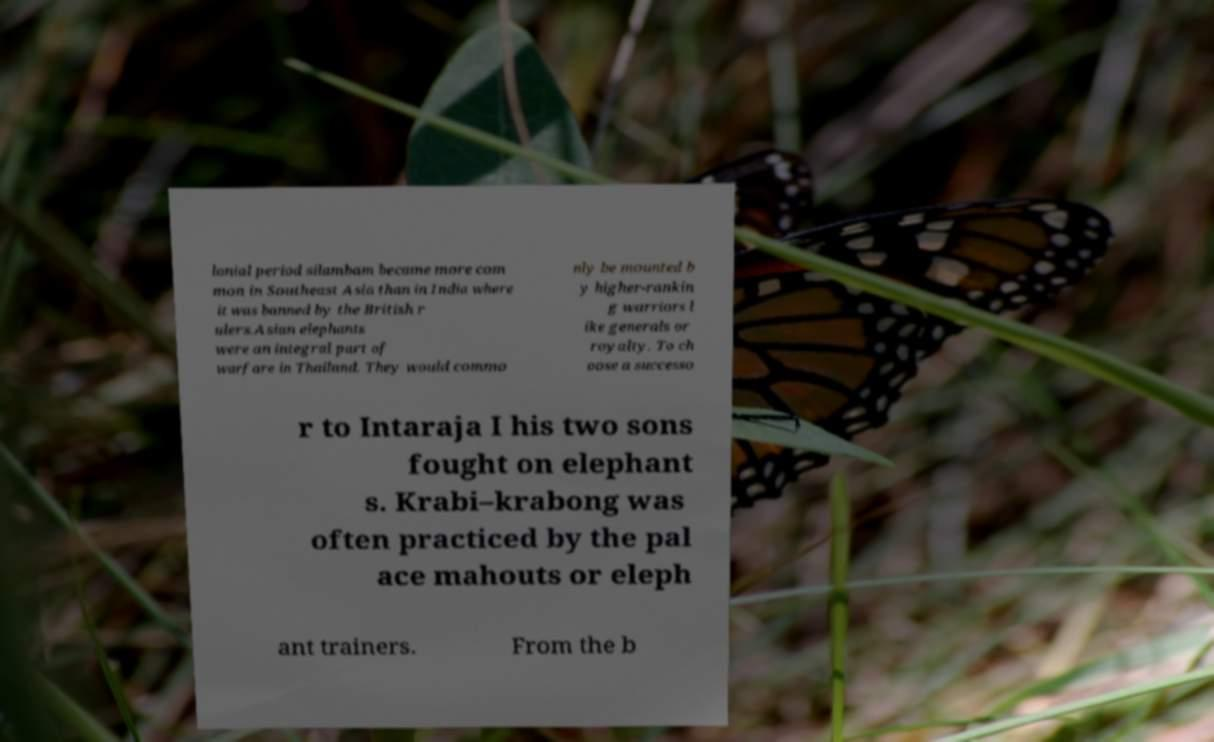Could you extract and type out the text from this image? lonial period silambam became more com mon in Southeast Asia than in India where it was banned by the British r ulers.Asian elephants were an integral part of warfare in Thailand. They would commo nly be mounted b y higher-rankin g warriors l ike generals or royalty. To ch oose a successo r to Intaraja I his two sons fought on elephant s. Krabi–krabong was often practiced by the pal ace mahouts or eleph ant trainers. From the b 